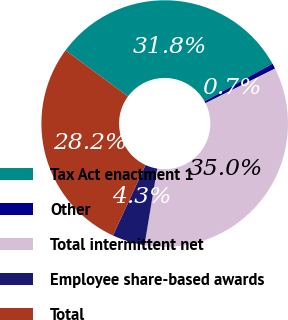<chart> <loc_0><loc_0><loc_500><loc_500><pie_chart><fcel>Tax Act enactment 1<fcel>Other<fcel>Total intermittent net<fcel>Employee share-based awards<fcel>Total<nl><fcel>31.8%<fcel>0.71%<fcel>34.98%<fcel>4.27%<fcel>28.24%<nl></chart> 